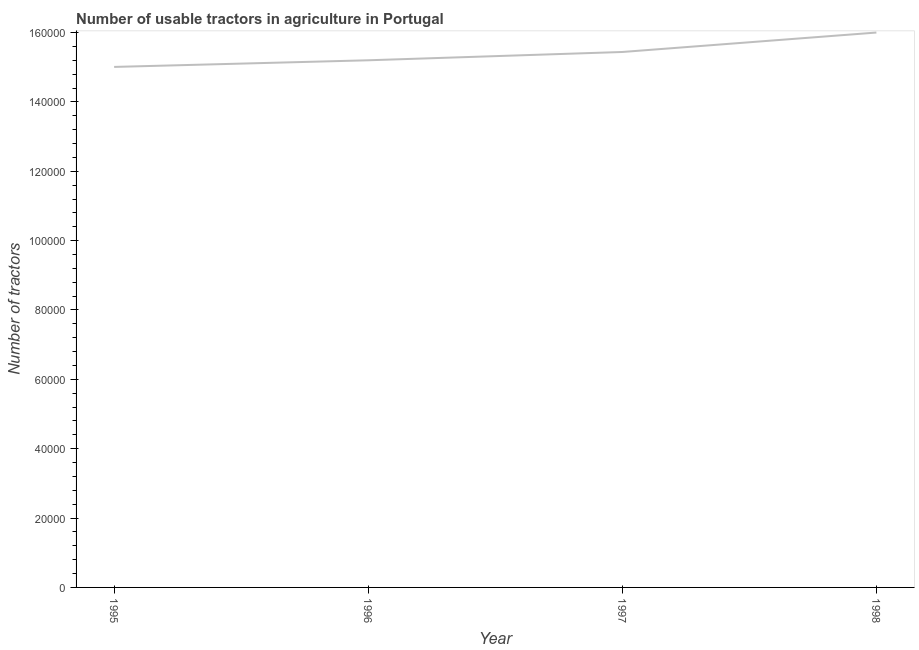What is the number of tractors in 1997?
Provide a short and direct response. 1.54e+05. Across all years, what is the maximum number of tractors?
Your response must be concise. 1.60e+05. Across all years, what is the minimum number of tractors?
Provide a succinct answer. 1.50e+05. What is the sum of the number of tractors?
Provide a short and direct response. 6.16e+05. What is the difference between the number of tractors in 1995 and 1996?
Your answer should be very brief. -1913. What is the average number of tractors per year?
Ensure brevity in your answer.  1.54e+05. What is the median number of tractors?
Keep it short and to the point. 1.53e+05. What is the ratio of the number of tractors in 1995 to that in 1998?
Your answer should be compact. 0.94. Is the difference between the number of tractors in 1997 and 1998 greater than the difference between any two years?
Make the answer very short. No. What is the difference between the highest and the second highest number of tractors?
Your answer should be very brief. 5607. Is the sum of the number of tractors in 1996 and 1997 greater than the maximum number of tractors across all years?
Provide a succinct answer. Yes. What is the difference between the highest and the lowest number of tractors?
Offer a very short reply. 9913. In how many years, is the number of tractors greater than the average number of tractors taken over all years?
Your answer should be very brief. 2. How many years are there in the graph?
Your answer should be very brief. 4. Are the values on the major ticks of Y-axis written in scientific E-notation?
Your answer should be very brief. No. Does the graph contain any zero values?
Offer a terse response. No. What is the title of the graph?
Offer a terse response. Number of usable tractors in agriculture in Portugal. What is the label or title of the X-axis?
Make the answer very short. Year. What is the label or title of the Y-axis?
Provide a succinct answer. Number of tractors. What is the Number of tractors of 1995?
Ensure brevity in your answer.  1.50e+05. What is the Number of tractors in 1996?
Your response must be concise. 1.52e+05. What is the Number of tractors in 1997?
Keep it short and to the point. 1.54e+05. What is the difference between the Number of tractors in 1995 and 1996?
Offer a terse response. -1913. What is the difference between the Number of tractors in 1995 and 1997?
Offer a very short reply. -4306. What is the difference between the Number of tractors in 1995 and 1998?
Your answer should be very brief. -9913. What is the difference between the Number of tractors in 1996 and 1997?
Your answer should be very brief. -2393. What is the difference between the Number of tractors in 1996 and 1998?
Provide a succinct answer. -8000. What is the difference between the Number of tractors in 1997 and 1998?
Provide a short and direct response. -5607. What is the ratio of the Number of tractors in 1995 to that in 1996?
Your answer should be very brief. 0.99. What is the ratio of the Number of tractors in 1995 to that in 1997?
Offer a terse response. 0.97. What is the ratio of the Number of tractors in 1995 to that in 1998?
Keep it short and to the point. 0.94. What is the ratio of the Number of tractors in 1996 to that in 1998?
Make the answer very short. 0.95. What is the ratio of the Number of tractors in 1997 to that in 1998?
Ensure brevity in your answer.  0.96. 